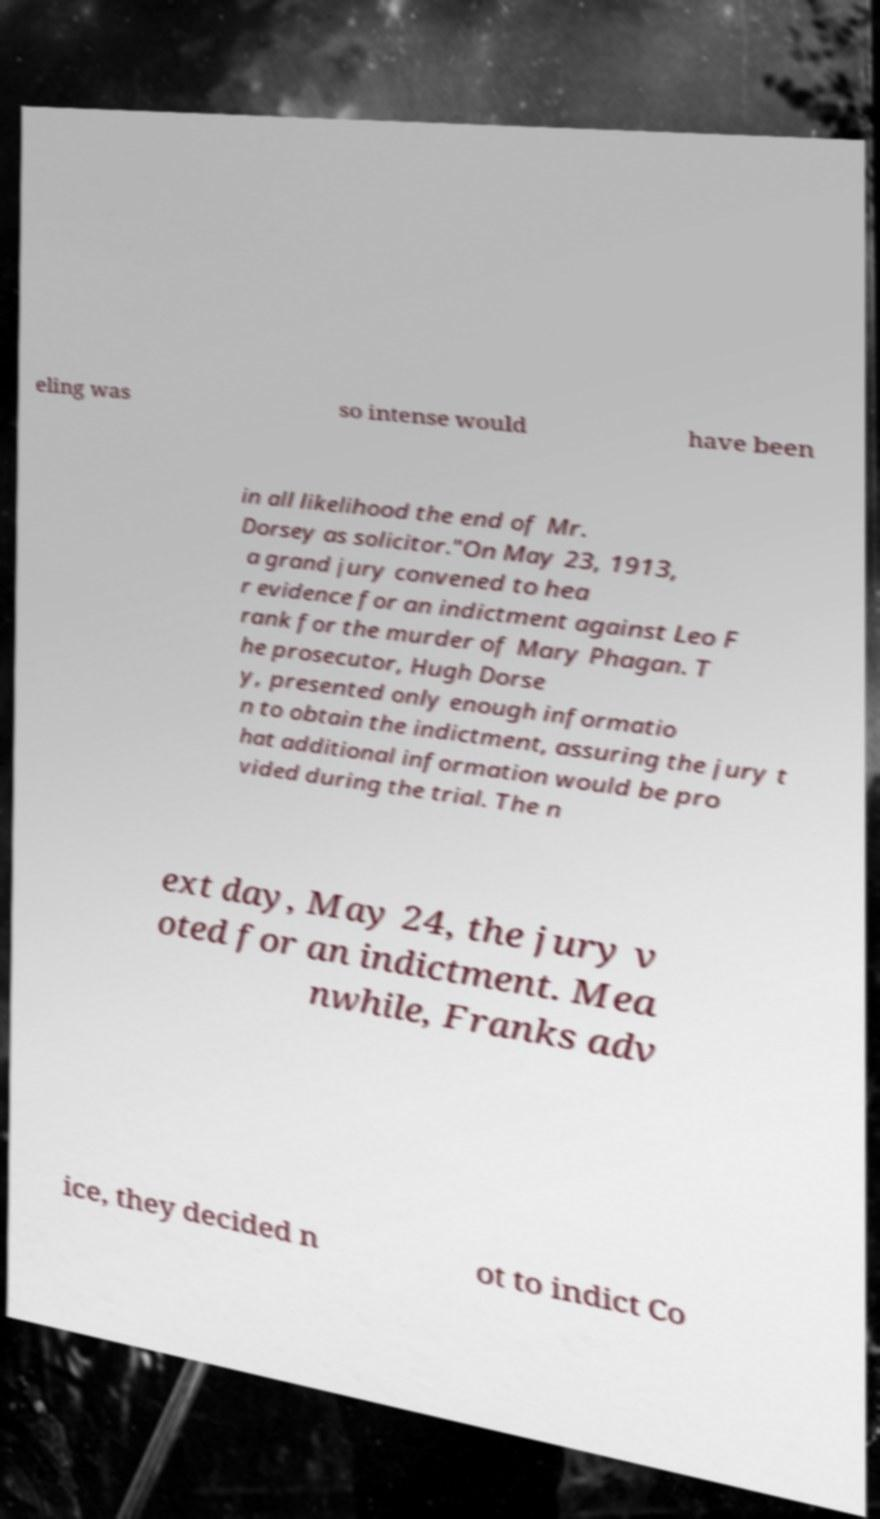Could you assist in decoding the text presented in this image and type it out clearly? eling was so intense would have been in all likelihood the end of Mr. Dorsey as solicitor."On May 23, 1913, a grand jury convened to hea r evidence for an indictment against Leo F rank for the murder of Mary Phagan. T he prosecutor, Hugh Dorse y, presented only enough informatio n to obtain the indictment, assuring the jury t hat additional information would be pro vided during the trial. The n ext day, May 24, the jury v oted for an indictment. Mea nwhile, Franks adv ice, they decided n ot to indict Co 